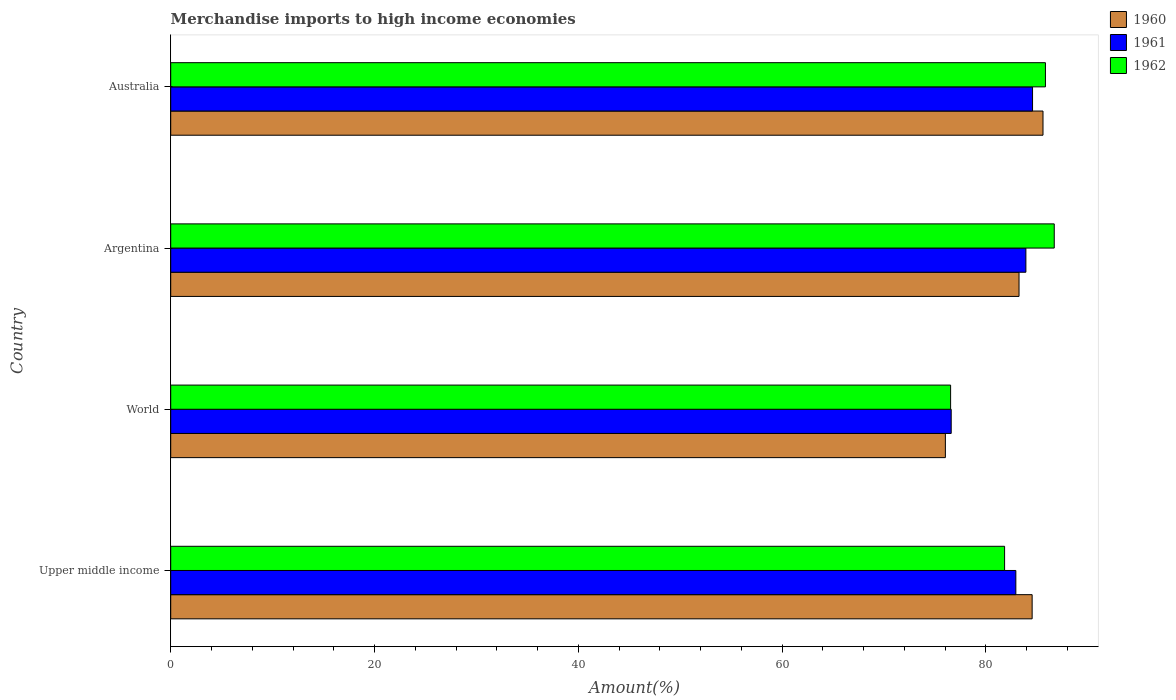How many groups of bars are there?
Ensure brevity in your answer.  4. Are the number of bars per tick equal to the number of legend labels?
Your answer should be compact. Yes. Are the number of bars on each tick of the Y-axis equal?
Provide a succinct answer. Yes. How many bars are there on the 2nd tick from the top?
Ensure brevity in your answer.  3. In how many cases, is the number of bars for a given country not equal to the number of legend labels?
Offer a terse response. 0. What is the percentage of amount earned from merchandise imports in 1961 in Argentina?
Make the answer very short. 83.92. Across all countries, what is the maximum percentage of amount earned from merchandise imports in 1961?
Your response must be concise. 84.57. Across all countries, what is the minimum percentage of amount earned from merchandise imports in 1960?
Give a very brief answer. 76.02. In which country was the percentage of amount earned from merchandise imports in 1960 maximum?
Give a very brief answer. Australia. In which country was the percentage of amount earned from merchandise imports in 1961 minimum?
Offer a very short reply. World. What is the total percentage of amount earned from merchandise imports in 1962 in the graph?
Keep it short and to the point. 330.91. What is the difference between the percentage of amount earned from merchandise imports in 1960 in Upper middle income and that in World?
Your response must be concise. 8.52. What is the difference between the percentage of amount earned from merchandise imports in 1960 in Argentina and the percentage of amount earned from merchandise imports in 1961 in Upper middle income?
Provide a short and direct response. 0.31. What is the average percentage of amount earned from merchandise imports in 1960 per country?
Offer a terse response. 82.35. What is the difference between the percentage of amount earned from merchandise imports in 1961 and percentage of amount earned from merchandise imports in 1960 in Argentina?
Give a very brief answer. 0.67. What is the ratio of the percentage of amount earned from merchandise imports in 1961 in Argentina to that in Australia?
Your answer should be compact. 0.99. What is the difference between the highest and the second highest percentage of amount earned from merchandise imports in 1962?
Your answer should be compact. 0.87. What is the difference between the highest and the lowest percentage of amount earned from merchandise imports in 1962?
Make the answer very short. 10.17. Is it the case that in every country, the sum of the percentage of amount earned from merchandise imports in 1962 and percentage of amount earned from merchandise imports in 1960 is greater than the percentage of amount earned from merchandise imports in 1961?
Give a very brief answer. Yes. How many bars are there?
Your answer should be very brief. 12. How many countries are there in the graph?
Your answer should be compact. 4. What is the title of the graph?
Offer a terse response. Merchandise imports to high income economies. Does "1965" appear as one of the legend labels in the graph?
Your response must be concise. No. What is the label or title of the X-axis?
Provide a succinct answer. Amount(%). What is the Amount(%) in 1960 in Upper middle income?
Ensure brevity in your answer.  84.54. What is the Amount(%) of 1961 in Upper middle income?
Provide a succinct answer. 82.94. What is the Amount(%) in 1962 in Upper middle income?
Provide a short and direct response. 81.83. What is the Amount(%) in 1960 in World?
Provide a short and direct response. 76.02. What is the Amount(%) in 1961 in World?
Offer a terse response. 76.59. What is the Amount(%) of 1962 in World?
Make the answer very short. 76.53. What is the Amount(%) of 1960 in Argentina?
Give a very brief answer. 83.25. What is the Amount(%) of 1961 in Argentina?
Keep it short and to the point. 83.92. What is the Amount(%) in 1962 in Argentina?
Provide a succinct answer. 86.7. What is the Amount(%) in 1960 in Australia?
Give a very brief answer. 85.6. What is the Amount(%) in 1961 in Australia?
Provide a short and direct response. 84.57. What is the Amount(%) of 1962 in Australia?
Ensure brevity in your answer.  85.84. Across all countries, what is the maximum Amount(%) in 1960?
Provide a short and direct response. 85.6. Across all countries, what is the maximum Amount(%) of 1961?
Ensure brevity in your answer.  84.57. Across all countries, what is the maximum Amount(%) in 1962?
Make the answer very short. 86.7. Across all countries, what is the minimum Amount(%) of 1960?
Your answer should be compact. 76.02. Across all countries, what is the minimum Amount(%) of 1961?
Ensure brevity in your answer.  76.59. Across all countries, what is the minimum Amount(%) in 1962?
Your answer should be very brief. 76.53. What is the total Amount(%) of 1960 in the graph?
Give a very brief answer. 329.4. What is the total Amount(%) in 1961 in the graph?
Your answer should be compact. 328.02. What is the total Amount(%) of 1962 in the graph?
Give a very brief answer. 330.91. What is the difference between the Amount(%) in 1960 in Upper middle income and that in World?
Offer a terse response. 8.52. What is the difference between the Amount(%) in 1961 in Upper middle income and that in World?
Your response must be concise. 6.34. What is the difference between the Amount(%) in 1962 in Upper middle income and that in World?
Give a very brief answer. 5.3. What is the difference between the Amount(%) in 1960 in Upper middle income and that in Argentina?
Provide a short and direct response. 1.29. What is the difference between the Amount(%) in 1961 in Upper middle income and that in Argentina?
Your response must be concise. -0.99. What is the difference between the Amount(%) of 1962 in Upper middle income and that in Argentina?
Make the answer very short. -4.87. What is the difference between the Amount(%) of 1960 in Upper middle income and that in Australia?
Provide a short and direct response. -1.07. What is the difference between the Amount(%) in 1961 in Upper middle income and that in Australia?
Your answer should be compact. -1.64. What is the difference between the Amount(%) in 1962 in Upper middle income and that in Australia?
Your answer should be compact. -4.01. What is the difference between the Amount(%) of 1960 in World and that in Argentina?
Your answer should be compact. -7.23. What is the difference between the Amount(%) of 1961 in World and that in Argentina?
Provide a short and direct response. -7.33. What is the difference between the Amount(%) of 1962 in World and that in Argentina?
Ensure brevity in your answer.  -10.17. What is the difference between the Amount(%) in 1960 in World and that in Australia?
Your answer should be compact. -9.58. What is the difference between the Amount(%) in 1961 in World and that in Australia?
Offer a terse response. -7.98. What is the difference between the Amount(%) in 1962 in World and that in Australia?
Provide a short and direct response. -9.31. What is the difference between the Amount(%) of 1960 in Argentina and that in Australia?
Provide a succinct answer. -2.35. What is the difference between the Amount(%) of 1961 in Argentina and that in Australia?
Provide a short and direct response. -0.65. What is the difference between the Amount(%) of 1962 in Argentina and that in Australia?
Give a very brief answer. 0.87. What is the difference between the Amount(%) of 1960 in Upper middle income and the Amount(%) of 1961 in World?
Keep it short and to the point. 7.94. What is the difference between the Amount(%) in 1960 in Upper middle income and the Amount(%) in 1962 in World?
Provide a succinct answer. 8. What is the difference between the Amount(%) in 1961 in Upper middle income and the Amount(%) in 1962 in World?
Offer a terse response. 6.4. What is the difference between the Amount(%) of 1960 in Upper middle income and the Amount(%) of 1961 in Argentina?
Keep it short and to the point. 0.61. What is the difference between the Amount(%) in 1960 in Upper middle income and the Amount(%) in 1962 in Argentina?
Make the answer very short. -2.17. What is the difference between the Amount(%) of 1961 in Upper middle income and the Amount(%) of 1962 in Argentina?
Offer a terse response. -3.77. What is the difference between the Amount(%) of 1960 in Upper middle income and the Amount(%) of 1961 in Australia?
Make the answer very short. -0.04. What is the difference between the Amount(%) in 1960 in Upper middle income and the Amount(%) in 1962 in Australia?
Make the answer very short. -1.3. What is the difference between the Amount(%) in 1961 in Upper middle income and the Amount(%) in 1962 in Australia?
Your response must be concise. -2.9. What is the difference between the Amount(%) in 1960 in World and the Amount(%) in 1961 in Argentina?
Offer a terse response. -7.9. What is the difference between the Amount(%) of 1960 in World and the Amount(%) of 1962 in Argentina?
Ensure brevity in your answer.  -10.68. What is the difference between the Amount(%) in 1961 in World and the Amount(%) in 1962 in Argentina?
Offer a terse response. -10.11. What is the difference between the Amount(%) in 1960 in World and the Amount(%) in 1961 in Australia?
Offer a terse response. -8.55. What is the difference between the Amount(%) of 1960 in World and the Amount(%) of 1962 in Australia?
Provide a succinct answer. -9.82. What is the difference between the Amount(%) in 1961 in World and the Amount(%) in 1962 in Australia?
Ensure brevity in your answer.  -9.25. What is the difference between the Amount(%) in 1960 in Argentina and the Amount(%) in 1961 in Australia?
Provide a succinct answer. -1.33. What is the difference between the Amount(%) in 1960 in Argentina and the Amount(%) in 1962 in Australia?
Offer a terse response. -2.59. What is the difference between the Amount(%) in 1961 in Argentina and the Amount(%) in 1962 in Australia?
Provide a short and direct response. -1.92. What is the average Amount(%) of 1960 per country?
Your answer should be compact. 82.35. What is the average Amount(%) in 1961 per country?
Provide a succinct answer. 82.01. What is the average Amount(%) in 1962 per country?
Keep it short and to the point. 82.73. What is the difference between the Amount(%) of 1960 and Amount(%) of 1961 in Upper middle income?
Provide a succinct answer. 1.6. What is the difference between the Amount(%) of 1960 and Amount(%) of 1962 in Upper middle income?
Make the answer very short. 2.7. What is the difference between the Amount(%) of 1961 and Amount(%) of 1962 in Upper middle income?
Keep it short and to the point. 1.1. What is the difference between the Amount(%) of 1960 and Amount(%) of 1961 in World?
Your answer should be compact. -0.57. What is the difference between the Amount(%) of 1960 and Amount(%) of 1962 in World?
Your answer should be very brief. -0.51. What is the difference between the Amount(%) of 1961 and Amount(%) of 1962 in World?
Your response must be concise. 0.06. What is the difference between the Amount(%) in 1960 and Amount(%) in 1961 in Argentina?
Your answer should be compact. -0.67. What is the difference between the Amount(%) of 1960 and Amount(%) of 1962 in Argentina?
Provide a short and direct response. -3.46. What is the difference between the Amount(%) in 1961 and Amount(%) in 1962 in Argentina?
Provide a succinct answer. -2.78. What is the difference between the Amount(%) in 1960 and Amount(%) in 1961 in Australia?
Make the answer very short. 1.03. What is the difference between the Amount(%) in 1960 and Amount(%) in 1962 in Australia?
Ensure brevity in your answer.  -0.24. What is the difference between the Amount(%) in 1961 and Amount(%) in 1962 in Australia?
Give a very brief answer. -1.27. What is the ratio of the Amount(%) of 1960 in Upper middle income to that in World?
Your response must be concise. 1.11. What is the ratio of the Amount(%) of 1961 in Upper middle income to that in World?
Offer a very short reply. 1.08. What is the ratio of the Amount(%) of 1962 in Upper middle income to that in World?
Offer a terse response. 1.07. What is the ratio of the Amount(%) of 1960 in Upper middle income to that in Argentina?
Offer a terse response. 1.02. What is the ratio of the Amount(%) in 1961 in Upper middle income to that in Argentina?
Offer a very short reply. 0.99. What is the ratio of the Amount(%) of 1962 in Upper middle income to that in Argentina?
Offer a very short reply. 0.94. What is the ratio of the Amount(%) of 1960 in Upper middle income to that in Australia?
Offer a very short reply. 0.99. What is the ratio of the Amount(%) of 1961 in Upper middle income to that in Australia?
Your response must be concise. 0.98. What is the ratio of the Amount(%) in 1962 in Upper middle income to that in Australia?
Ensure brevity in your answer.  0.95. What is the ratio of the Amount(%) in 1960 in World to that in Argentina?
Your answer should be very brief. 0.91. What is the ratio of the Amount(%) of 1961 in World to that in Argentina?
Make the answer very short. 0.91. What is the ratio of the Amount(%) of 1962 in World to that in Argentina?
Keep it short and to the point. 0.88. What is the ratio of the Amount(%) in 1960 in World to that in Australia?
Offer a terse response. 0.89. What is the ratio of the Amount(%) of 1961 in World to that in Australia?
Provide a short and direct response. 0.91. What is the ratio of the Amount(%) of 1962 in World to that in Australia?
Keep it short and to the point. 0.89. What is the ratio of the Amount(%) of 1960 in Argentina to that in Australia?
Offer a very short reply. 0.97. What is the ratio of the Amount(%) of 1962 in Argentina to that in Australia?
Offer a very short reply. 1.01. What is the difference between the highest and the second highest Amount(%) of 1960?
Give a very brief answer. 1.07. What is the difference between the highest and the second highest Amount(%) of 1961?
Offer a terse response. 0.65. What is the difference between the highest and the second highest Amount(%) of 1962?
Offer a very short reply. 0.87. What is the difference between the highest and the lowest Amount(%) in 1960?
Ensure brevity in your answer.  9.58. What is the difference between the highest and the lowest Amount(%) in 1961?
Make the answer very short. 7.98. What is the difference between the highest and the lowest Amount(%) in 1962?
Provide a short and direct response. 10.17. 